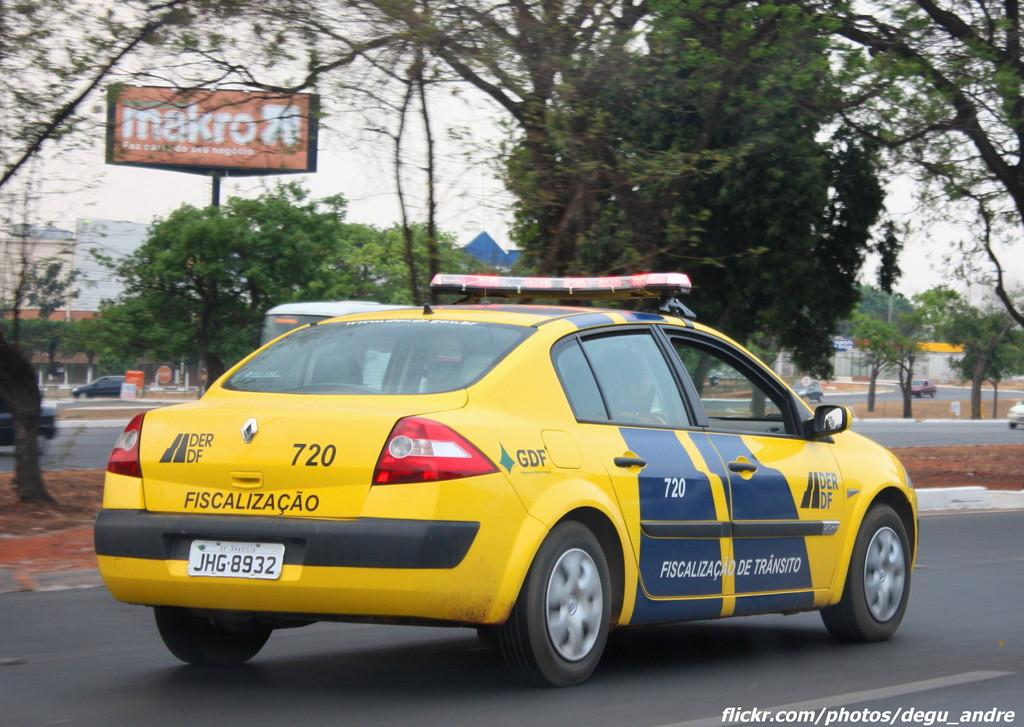<image>
Give a short and clear explanation of the subsequent image. A yellow car with sirens on top says Fiscalizacao on the back. 